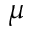<formula> <loc_0><loc_0><loc_500><loc_500>\mu</formula> 